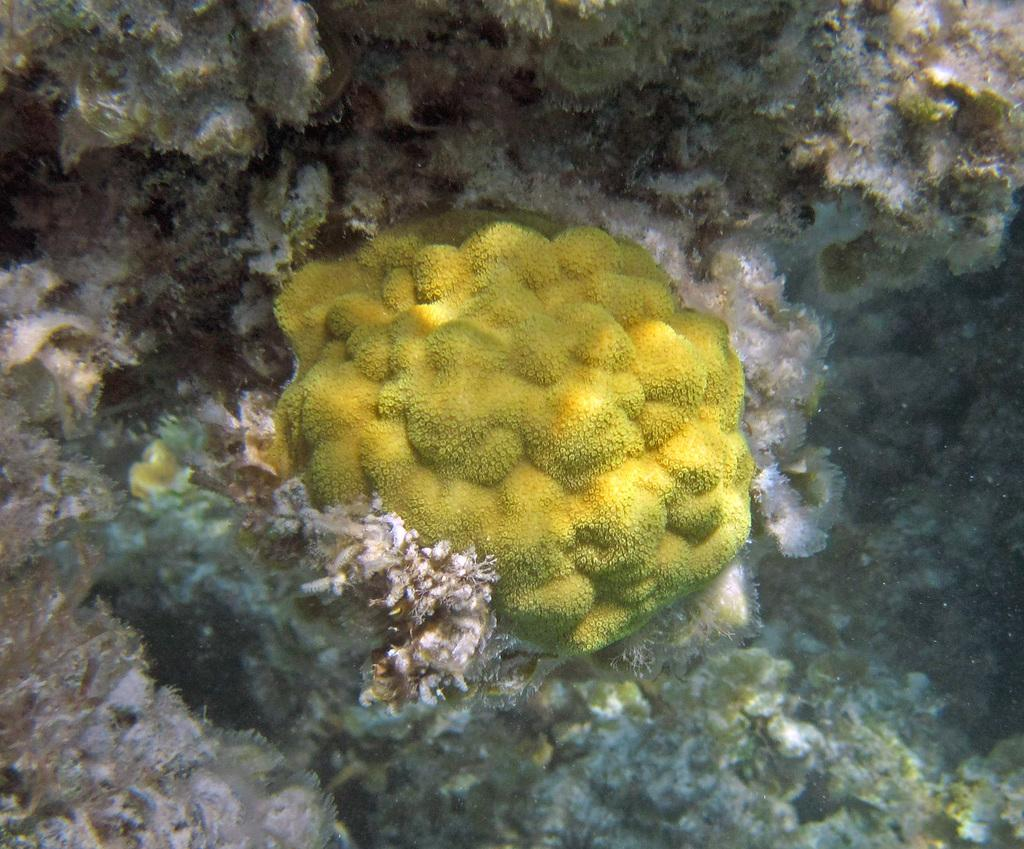What type of environment is depicted in the image? The image is an underwater picture. What type of plant life can be seen in the image? There is green algae or fungi visible in the image. What type of yoke is being used by the fish in the image? There are no fish or yokes present in the image; it is an underwater picture with green algae or fungi. 